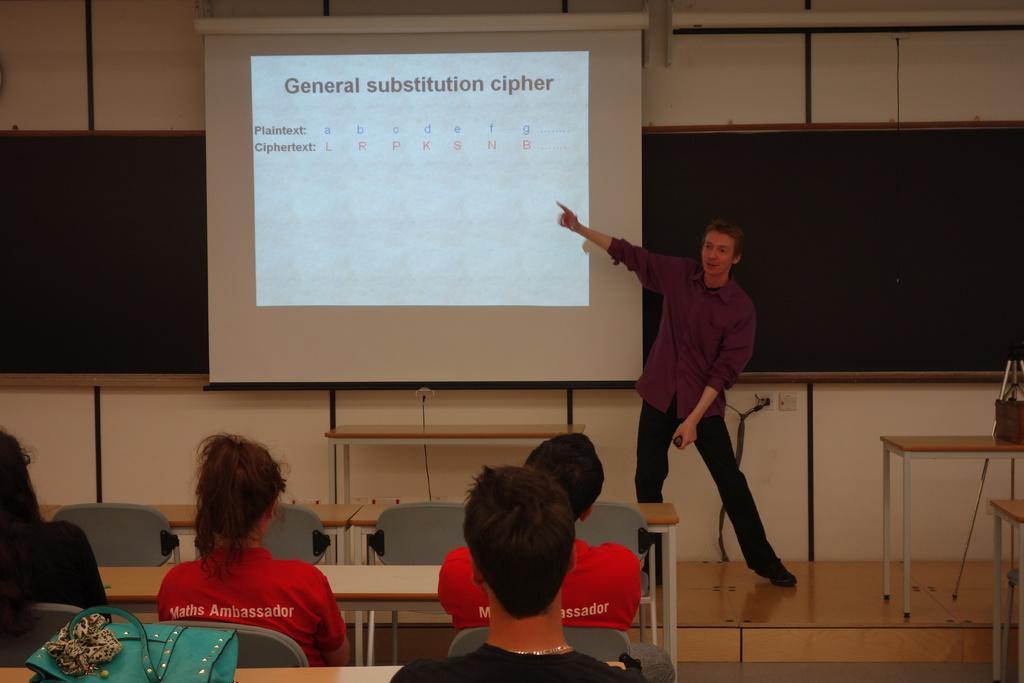Describe this image in one or two sentences. In the center of the image a man is standing and holding an object and explaining something. At the bottom of the image some persons are sitting on a chair and we can see tables, bag are there. In the middle of the image we can see screen, board, wall are present. On the right side of the image tables are there. In the middle of the image floor is there. 